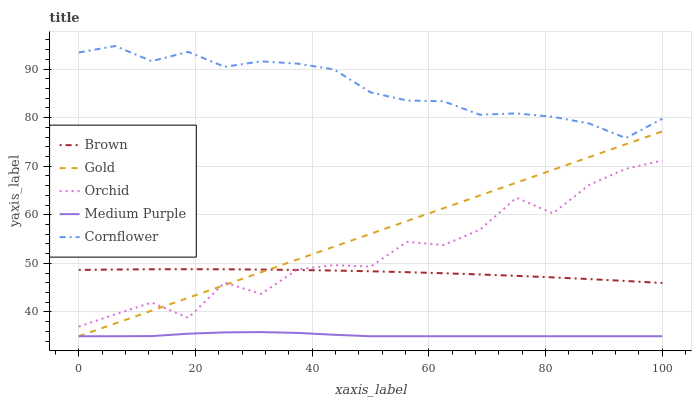Does Medium Purple have the minimum area under the curve?
Answer yes or no. Yes. Does Cornflower have the maximum area under the curve?
Answer yes or no. Yes. Does Brown have the minimum area under the curve?
Answer yes or no. No. Does Brown have the maximum area under the curve?
Answer yes or no. No. Is Gold the smoothest?
Answer yes or no. Yes. Is Orchid the roughest?
Answer yes or no. Yes. Is Brown the smoothest?
Answer yes or no. No. Is Brown the roughest?
Answer yes or no. No. Does Brown have the lowest value?
Answer yes or no. No. Does Cornflower have the highest value?
Answer yes or no. Yes. Does Brown have the highest value?
Answer yes or no. No. Is Brown less than Cornflower?
Answer yes or no. Yes. Is Orchid greater than Medium Purple?
Answer yes or no. Yes. Does Gold intersect Orchid?
Answer yes or no. Yes. Is Gold less than Orchid?
Answer yes or no. No. Is Gold greater than Orchid?
Answer yes or no. No. Does Brown intersect Cornflower?
Answer yes or no. No. 